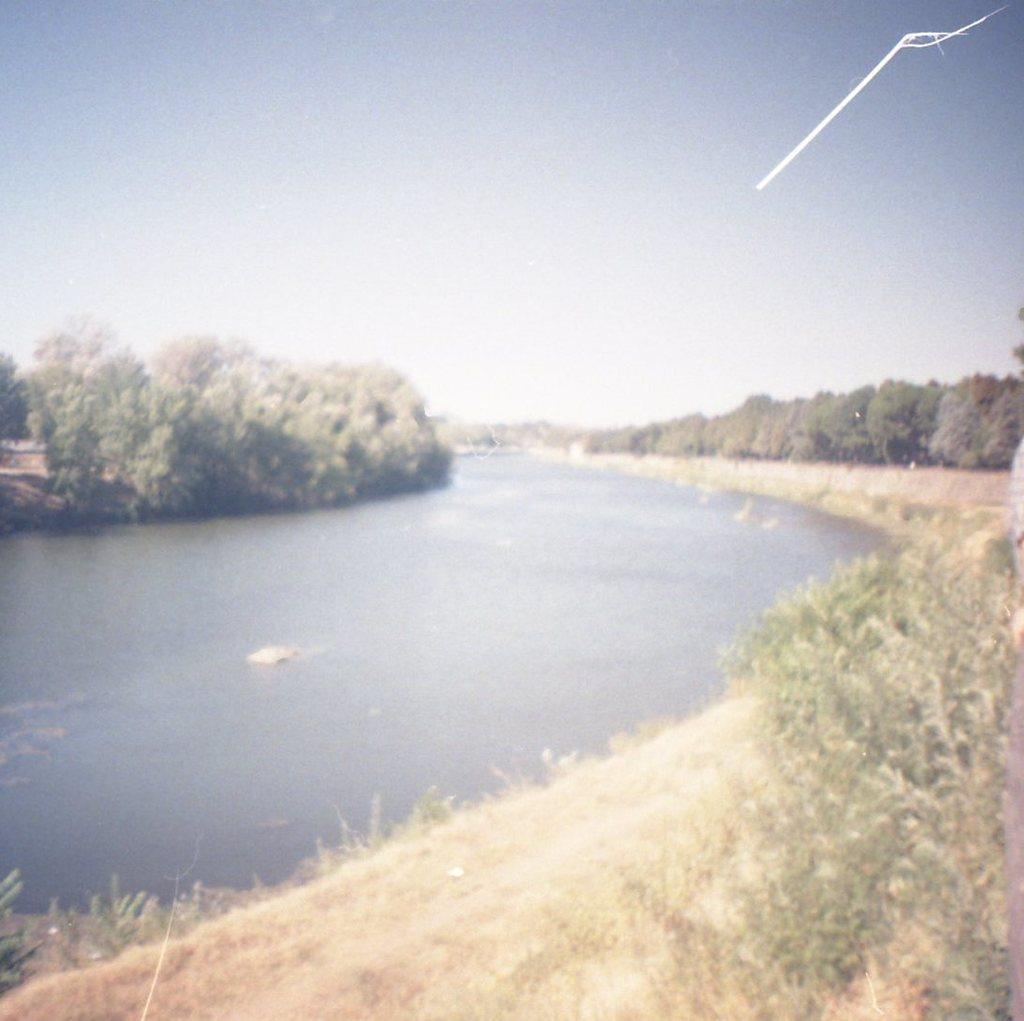What type of natural feature is present in the picture? There is a river in the picture. What can be found in the river? There are rocks in the river. What other elements are present in the picture? There are plants, trees on the right side, and trees on the left side of the picture. How would you describe the sky in the picture? The sky is clear in the picture. What type of straw is being used by the pig in the picture? There is no pig or straw present in the picture; it features a river with rocks and trees. How many socks can be seen on the trees in the picture? There are no socks present in the picture; it features a river with rocks and trees. 